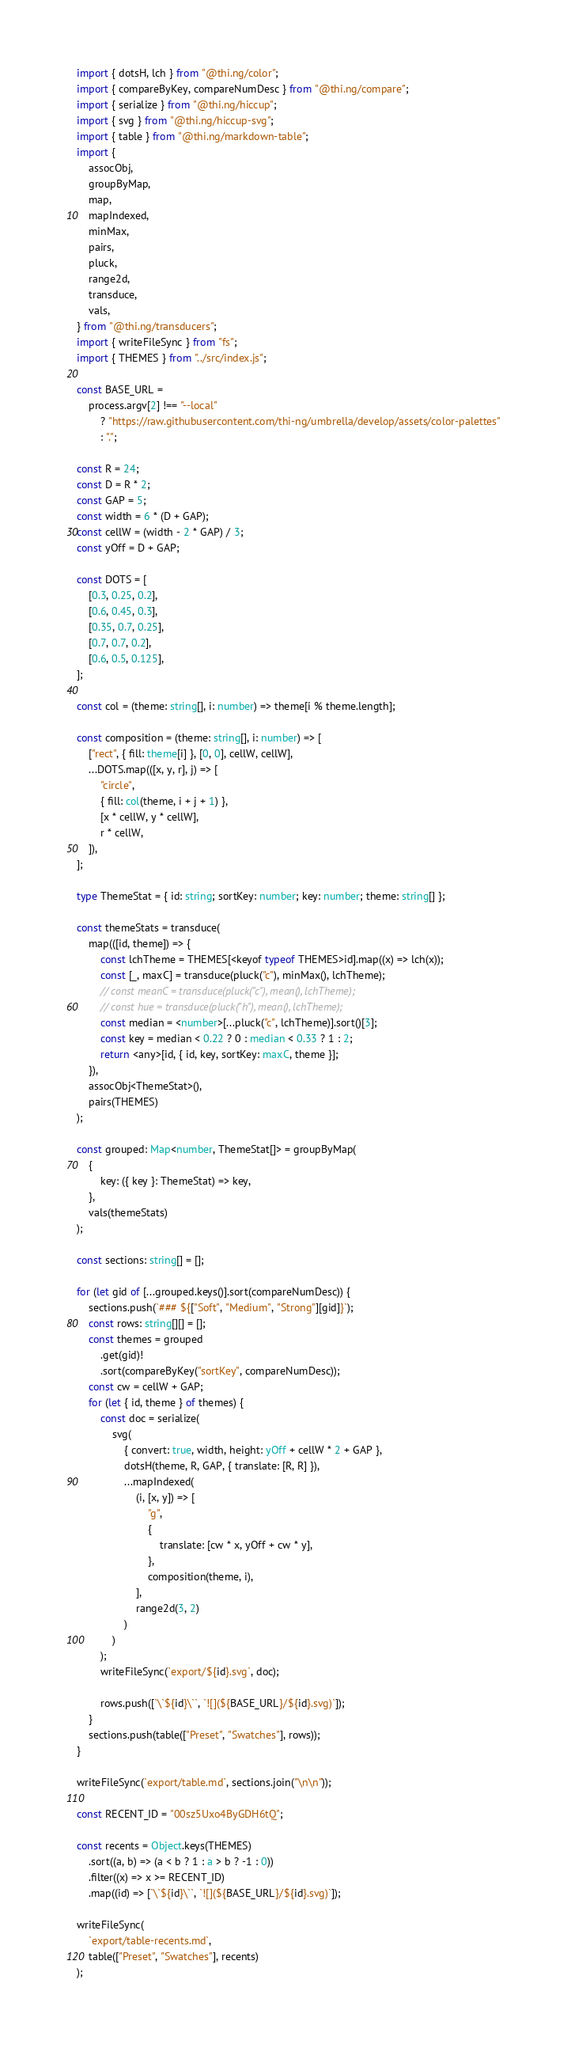Convert code to text. <code><loc_0><loc_0><loc_500><loc_500><_TypeScript_>import { dotsH, lch } from "@thi.ng/color";
import { compareByKey, compareNumDesc } from "@thi.ng/compare";
import { serialize } from "@thi.ng/hiccup";
import { svg } from "@thi.ng/hiccup-svg";
import { table } from "@thi.ng/markdown-table";
import {
    assocObj,
    groupByMap,
    map,
    mapIndexed,
    minMax,
    pairs,
    pluck,
    range2d,
    transduce,
    vals,
} from "@thi.ng/transducers";
import { writeFileSync } from "fs";
import { THEMES } from "../src/index.js";

const BASE_URL =
    process.argv[2] !== "--local"
        ? "https://raw.githubusercontent.com/thi-ng/umbrella/develop/assets/color-palettes"
        : ".";

const R = 24;
const D = R * 2;
const GAP = 5;
const width = 6 * (D + GAP);
const cellW = (width - 2 * GAP) / 3;
const yOff = D + GAP;

const DOTS = [
    [0.3, 0.25, 0.2],
    [0.6, 0.45, 0.3],
    [0.35, 0.7, 0.25],
    [0.7, 0.7, 0.2],
    [0.6, 0.5, 0.125],
];

const col = (theme: string[], i: number) => theme[i % theme.length];

const composition = (theme: string[], i: number) => [
    ["rect", { fill: theme[i] }, [0, 0], cellW, cellW],
    ...DOTS.map(([x, y, r], j) => [
        "circle",
        { fill: col(theme, i + j + 1) },
        [x * cellW, y * cellW],
        r * cellW,
    ]),
];

type ThemeStat = { id: string; sortKey: number; key: number; theme: string[] };

const themeStats = transduce(
    map(([id, theme]) => {
        const lchTheme = THEMES[<keyof typeof THEMES>id].map((x) => lch(x));
        const [_, maxC] = transduce(pluck("c"), minMax(), lchTheme);
        // const meanC = transduce(pluck("c"), mean(), lchTheme);
        // const hue = transduce(pluck("h"), mean(), lchTheme);
        const median = <number>[...pluck("c", lchTheme)].sort()[3];
        const key = median < 0.22 ? 0 : median < 0.33 ? 1 : 2;
        return <any>[id, { id, key, sortKey: maxC, theme }];
    }),
    assocObj<ThemeStat>(),
    pairs(THEMES)
);

const grouped: Map<number, ThemeStat[]> = groupByMap(
    {
        key: ({ key }: ThemeStat) => key,
    },
    vals(themeStats)
);

const sections: string[] = [];

for (let gid of [...grouped.keys()].sort(compareNumDesc)) {
    sections.push(`### ${["Soft", "Medium", "Strong"][gid]}`);
    const rows: string[][] = [];
    const themes = grouped
        .get(gid)!
        .sort(compareByKey("sortKey", compareNumDesc));
    const cw = cellW + GAP;
    for (let { id, theme } of themes) {
        const doc = serialize(
            svg(
                { convert: true, width, height: yOff + cellW * 2 + GAP },
                dotsH(theme, R, GAP, { translate: [R, R] }),
                ...mapIndexed(
                    (i, [x, y]) => [
                        "g",
                        {
                            translate: [cw * x, yOff + cw * y],
                        },
                        composition(theme, i),
                    ],
                    range2d(3, 2)
                )
            )
        );
        writeFileSync(`export/${id}.svg`, doc);

        rows.push([`\`${id}\``, `![](${BASE_URL}/${id}.svg)`]);
    }
    sections.push(table(["Preset", "Swatches"], rows));
}

writeFileSync(`export/table.md`, sections.join("\n\n"));

const RECENT_ID = "00sz5Uxo4ByGDH6tQ";

const recents = Object.keys(THEMES)
    .sort((a, b) => (a < b ? 1 : a > b ? -1 : 0))
    .filter((x) => x >= RECENT_ID)
    .map((id) => [`\`${id}\``, `![](${BASE_URL}/${id}.svg)`]);

writeFileSync(
    `export/table-recents.md`,
    table(["Preset", "Swatches"], recents)
);
</code> 